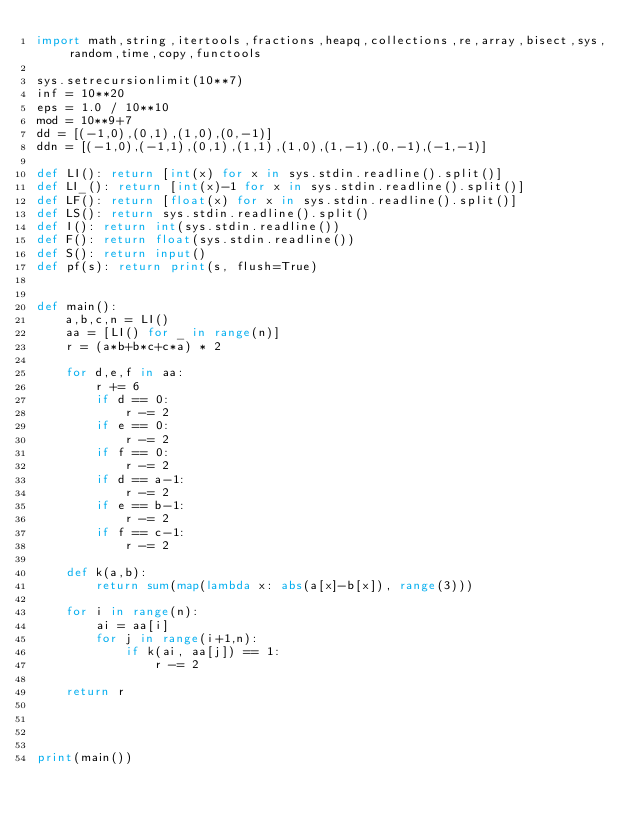<code> <loc_0><loc_0><loc_500><loc_500><_Python_>import math,string,itertools,fractions,heapq,collections,re,array,bisect,sys,random,time,copy,functools

sys.setrecursionlimit(10**7)
inf = 10**20
eps = 1.0 / 10**10
mod = 10**9+7
dd = [(-1,0),(0,1),(1,0),(0,-1)]
ddn = [(-1,0),(-1,1),(0,1),(1,1),(1,0),(1,-1),(0,-1),(-1,-1)]

def LI(): return [int(x) for x in sys.stdin.readline().split()]
def LI_(): return [int(x)-1 for x in sys.stdin.readline().split()]
def LF(): return [float(x) for x in sys.stdin.readline().split()]
def LS(): return sys.stdin.readline().split()
def I(): return int(sys.stdin.readline())
def F(): return float(sys.stdin.readline())
def S(): return input()
def pf(s): return print(s, flush=True)


def main():
    a,b,c,n = LI()
    aa = [LI() for _ in range(n)]
    r = (a*b+b*c+c*a) * 2

    for d,e,f in aa:
        r += 6
        if d == 0:
            r -= 2
        if e == 0:
            r -= 2
        if f == 0:
            r -= 2
        if d == a-1:
            r -= 2
        if e == b-1:
            r -= 2
        if f == c-1:
            r -= 2

    def k(a,b):
        return sum(map(lambda x: abs(a[x]-b[x]), range(3)))

    for i in range(n):
        ai = aa[i]
        for j in range(i+1,n):
            if k(ai, aa[j]) == 1:
                r -= 2

    return r




print(main())

</code> 